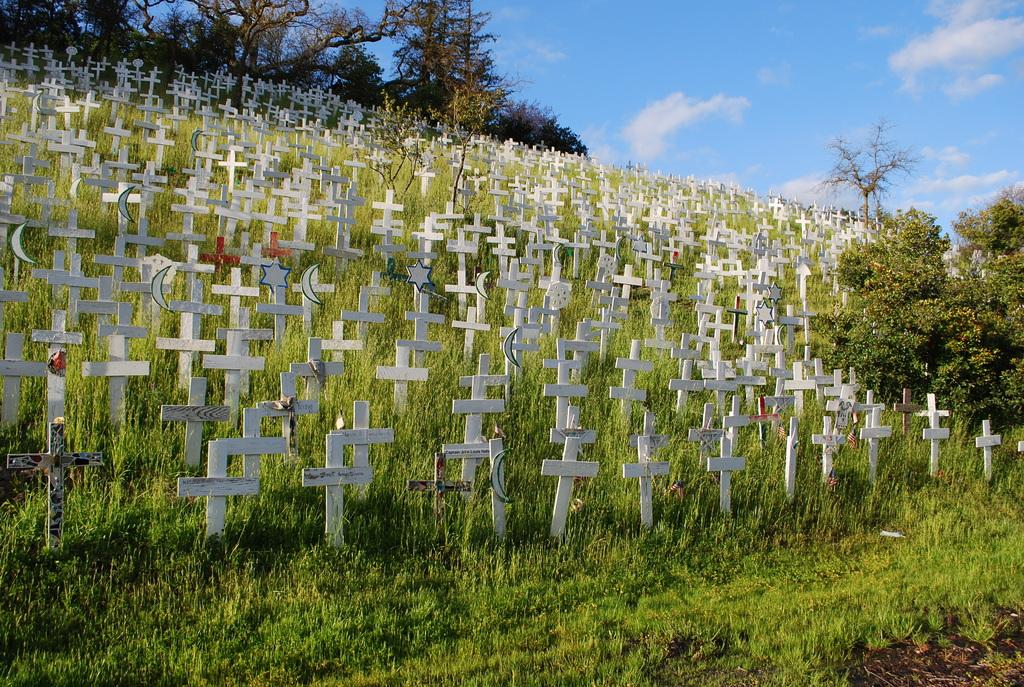What symbols can be seen on the ground in the foreground of the image? There are many cross symbols placed on the ground in the foreground of the image. What can be seen in the background of the image? There are trees and the sky visible in the background of the image. Can you describe the sky in the image? The sky is visible in the background of the image, and there is a cloud present. How many eyes can be seen on the goose in the image? There is no goose present in the image, so it is not possible to determine the number of eyes on a goose. 